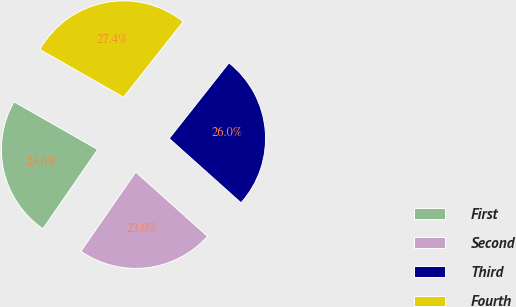<chart> <loc_0><loc_0><loc_500><loc_500><pie_chart><fcel>First<fcel>Second<fcel>Third<fcel>Fourth<nl><fcel>23.62%<fcel>23.01%<fcel>25.98%<fcel>27.39%<nl></chart> 